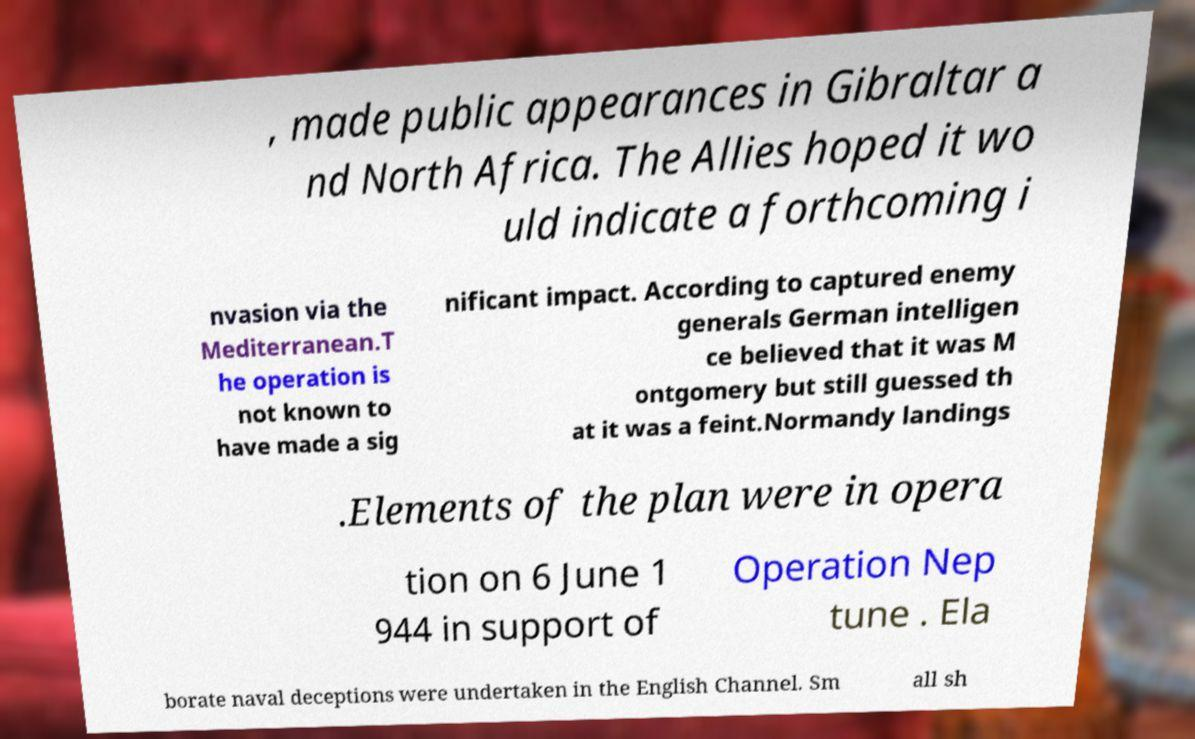For documentation purposes, I need the text within this image transcribed. Could you provide that? , made public appearances in Gibraltar a nd North Africa. The Allies hoped it wo uld indicate a forthcoming i nvasion via the Mediterranean.T he operation is not known to have made a sig nificant impact. According to captured enemy generals German intelligen ce believed that it was M ontgomery but still guessed th at it was a feint.Normandy landings .Elements of the plan were in opera tion on 6 June 1 944 in support of Operation Nep tune . Ela borate naval deceptions were undertaken in the English Channel. Sm all sh 